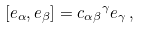Convert formula to latex. <formula><loc_0><loc_0><loc_500><loc_500>[ e _ { \alpha } , e _ { \beta } ] = { c _ { \alpha \beta } } ^ { \gamma } e _ { \gamma } \, ,</formula> 